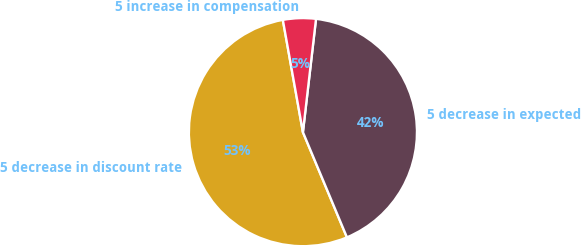Convert chart to OTSL. <chart><loc_0><loc_0><loc_500><loc_500><pie_chart><fcel>5 decrease in discount rate<fcel>5 decrease in expected<fcel>5 increase in compensation<nl><fcel>53.49%<fcel>41.86%<fcel>4.65%<nl></chart> 